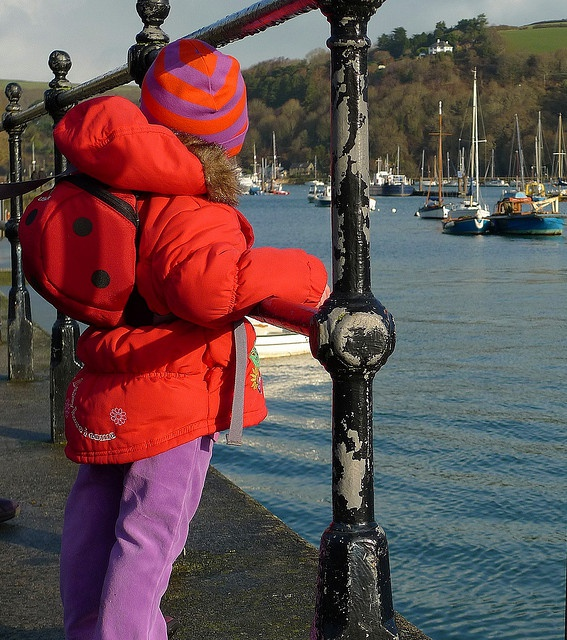Describe the objects in this image and their specific colors. I can see people in lightgray, red, maroon, violet, and black tones, backpack in lightgray, maroon, brown, and black tones, boat in lightgray, black, gray, and teal tones, boat in lightgray, black, gray, ivory, and darkgray tones, and boat in lightgray, black, gray, darkgray, and ivory tones in this image. 